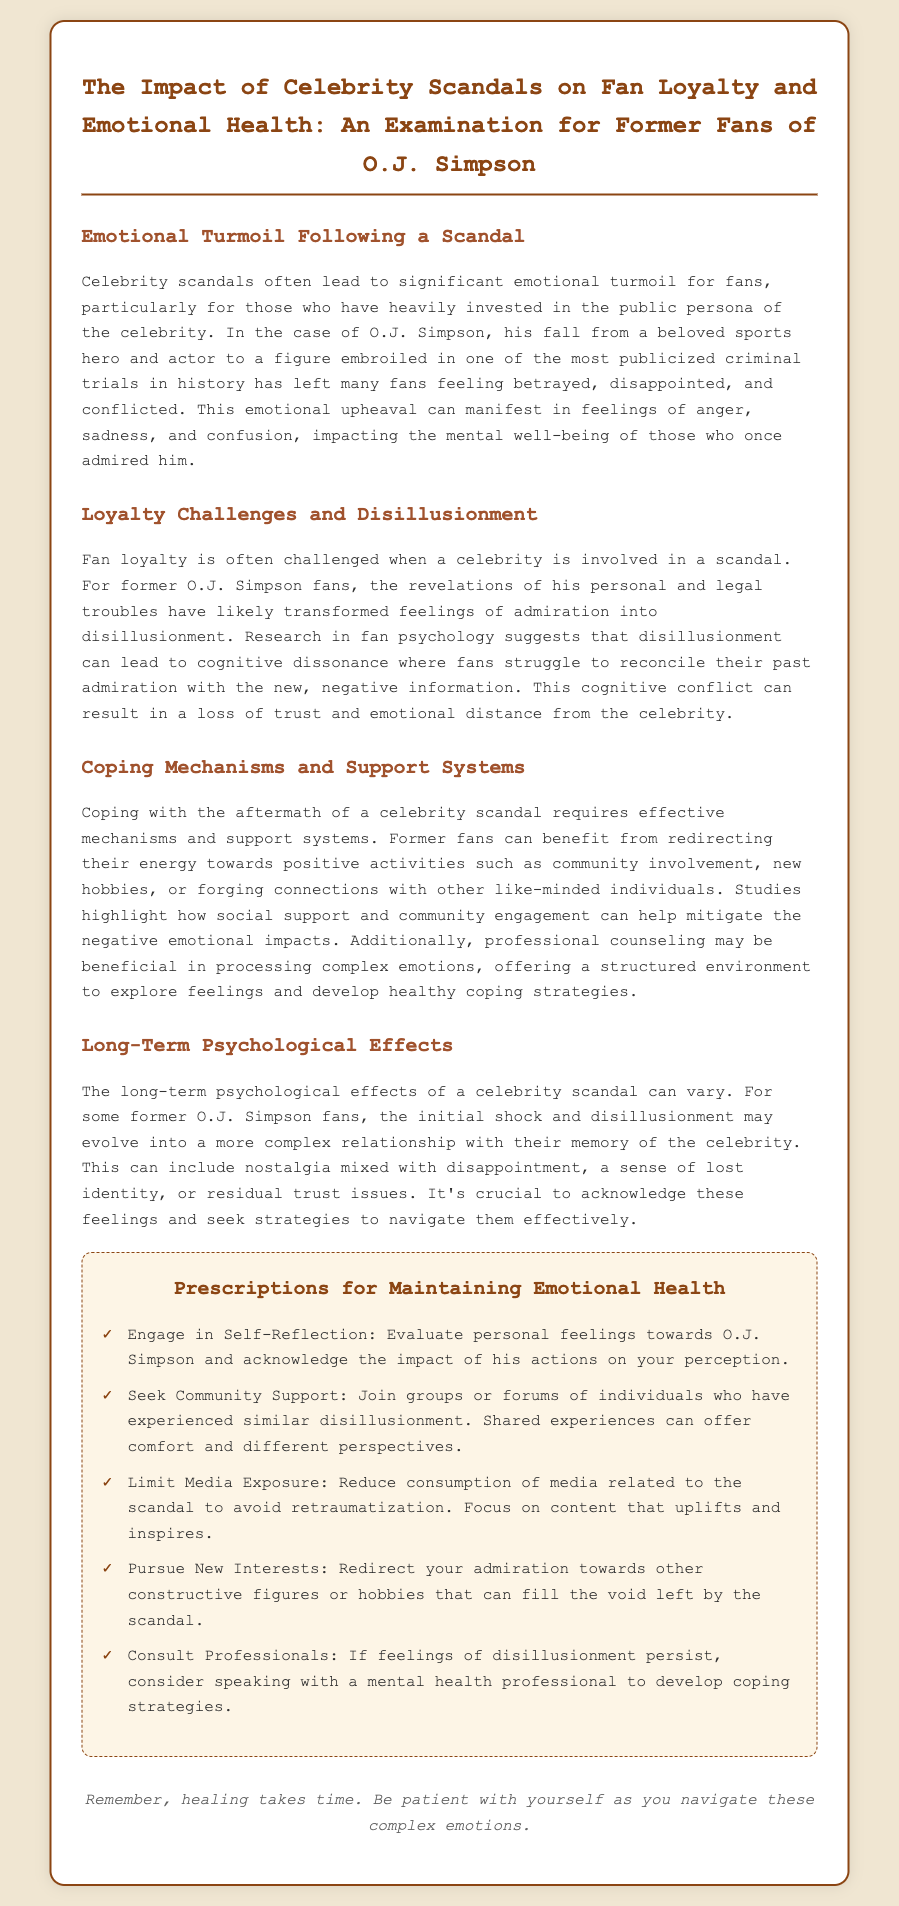what is the title of the document? The title of the document is displayed at the top and outlines its main focus.
Answer: The Impact of Celebrity Scandals on Fan Loyalty and Emotional Health: An Examination for Former Fans of O.J. Simpson who is the targeted audience of this prescription? The prescription targets individuals who have previously admired O.J. Simpson and have experienced disillusionment following his scandals.
Answer: Former Fans of O.J. Simpson what emotional feelings are mentioned that fans might experience after a scandal? The document lists emotional responses that fans may go through after a celebrity scandal.
Answer: Anger, sadness, and confusion what coping mechanism is suggested for managing disillusionment? The document outlines strategies for former fans to cope with their feelings.
Answer: Engage in Self-Reflection how many prescriptions are provided for maintaining emotional health? The document includes a specific number of strategies aimed at helping individuals maintain their emotional well-being.
Answer: Five what psychological effect may evolve from initial shock according to the document? The document describes a progression of emotions that can develop over time for disillusioned fans.
Answer: Nostalgia mixed with disappointment what is one of the long-term effects of a celebrity scandal mentioned? The document discusses possible long-term impacts on fans after exposure to a scandal.
Answer: Trust issues which professional help is recommended in the document? The prescription offers a specific type of support for fans struggling with their feelings.
Answer: Mental health professional 